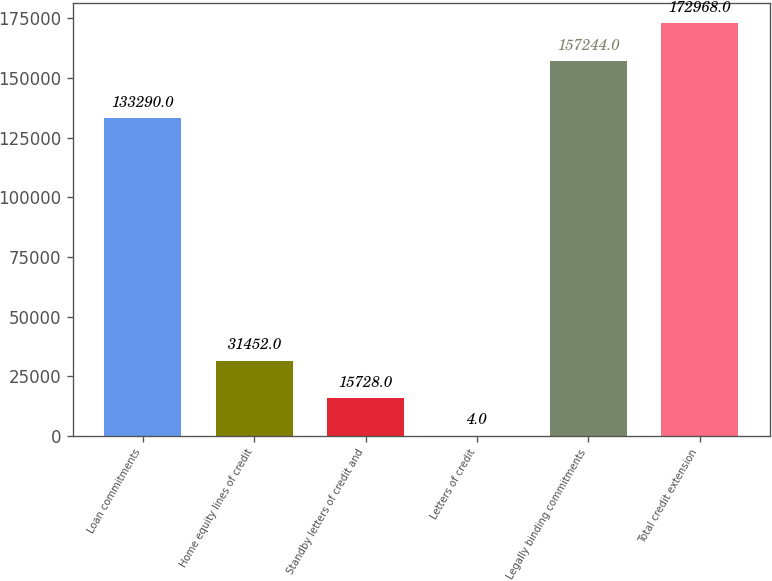<chart> <loc_0><loc_0><loc_500><loc_500><bar_chart><fcel>Loan commitments<fcel>Home equity lines of credit<fcel>Standby letters of credit and<fcel>Letters of credit<fcel>Legally binding commitments<fcel>Total credit extension<nl><fcel>133290<fcel>31452<fcel>15728<fcel>4<fcel>157244<fcel>172968<nl></chart> 